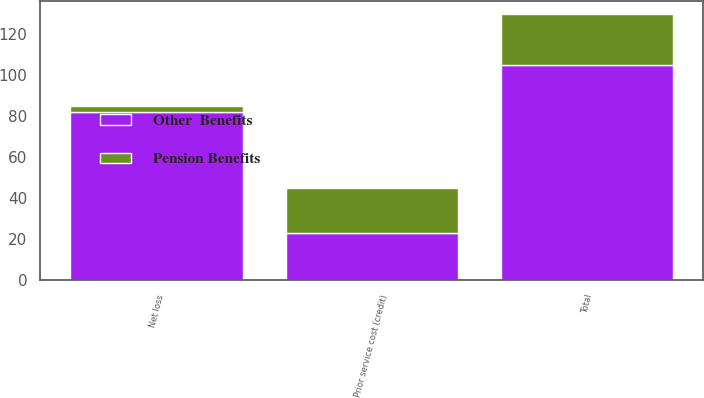Convert chart to OTSL. <chart><loc_0><loc_0><loc_500><loc_500><stacked_bar_chart><ecel><fcel>Prior service cost (credit)<fcel>Net loss<fcel>Total<nl><fcel>Other  Benefits<fcel>23<fcel>82<fcel>105<nl><fcel>Pension Benefits<fcel>22<fcel>3<fcel>25<nl></chart> 